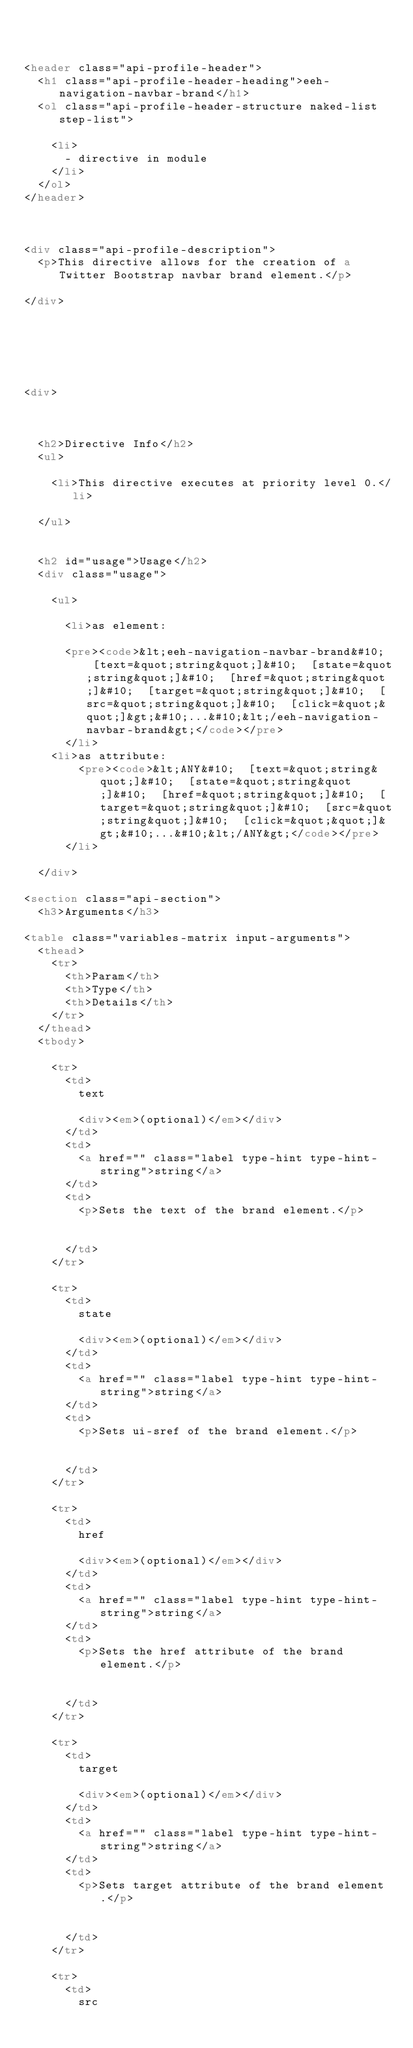<code> <loc_0><loc_0><loc_500><loc_500><_HTML_>


<header class="api-profile-header">
  <h1 class="api-profile-header-heading">eeh-navigation-navbar-brand</h1>
  <ol class="api-profile-header-structure naked-list step-list">
    
    <li>
      - directive in module 
    </li>
  </ol>
</header>



<div class="api-profile-description">
  <p>This directive allows for the creation of a Twitter Bootstrap navbar brand element.</p>

</div>






<div>
  

  
  <h2>Directive Info</h2>
  <ul>
    
    <li>This directive executes at priority level 0.</li>
    
  </ul>

  
  <h2 id="usage">Usage</h2>
  <div class="usage">
  
    <ul>
    
      <li>as element:
      
      <pre><code>&lt;eeh-navigation-navbar-brand&#10;  [text=&quot;string&quot;]&#10;  [state=&quot;string&quot;]&#10;  [href=&quot;string&quot;]&#10;  [target=&quot;string&quot;]&#10;  [src=&quot;string&quot;]&#10;  [click=&quot;&quot;]&gt;&#10;...&#10;&lt;/eeh-navigation-navbar-brand&gt;</code></pre>
      </li>
    <li>as attribute:
        <pre><code>&lt;ANY&#10;  [text=&quot;string&quot;]&#10;  [state=&quot;string&quot;]&#10;  [href=&quot;string&quot;]&#10;  [target=&quot;string&quot;]&#10;  [src=&quot;string&quot;]&#10;  [click=&quot;&quot;]&gt;&#10;...&#10;&lt;/ANY&gt;</code></pre>
      </li>
    
  </div>
  
<section class="api-section">
  <h3>Arguments</h3>

<table class="variables-matrix input-arguments">
  <thead>
    <tr>
      <th>Param</th>
      <th>Type</th>
      <th>Details</th>
    </tr>
  </thead>
  <tbody>
    
    <tr>
      <td>
        text
        
        <div><em>(optional)</em></div>
      </td>
      <td>
        <a href="" class="label type-hint type-hint-string">string</a>
      </td>
      <td>
        <p>Sets the text of the brand element.</p>

        
      </td>
    </tr>
    
    <tr>
      <td>
        state
        
        <div><em>(optional)</em></div>
      </td>
      <td>
        <a href="" class="label type-hint type-hint-string">string</a>
      </td>
      <td>
        <p>Sets ui-sref of the brand element.</p>

        
      </td>
    </tr>
    
    <tr>
      <td>
        href
        
        <div><em>(optional)</em></div>
      </td>
      <td>
        <a href="" class="label type-hint type-hint-string">string</a>
      </td>
      <td>
        <p>Sets the href attribute of the brand element.</p>

        
      </td>
    </tr>
    
    <tr>
      <td>
        target
        
        <div><em>(optional)</em></div>
      </td>
      <td>
        <a href="" class="label type-hint type-hint-string">string</a>
      </td>
      <td>
        <p>Sets target attribute of the brand element.</p>

        
      </td>
    </tr>
    
    <tr>
      <td>
        src
        </code> 